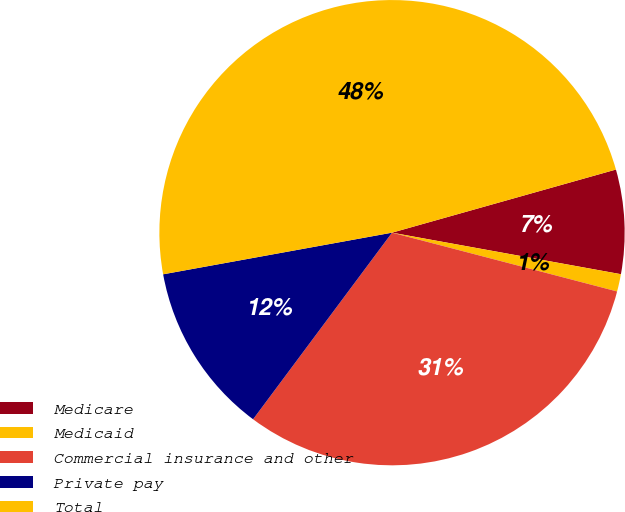Convert chart to OTSL. <chart><loc_0><loc_0><loc_500><loc_500><pie_chart><fcel>Medicare<fcel>Medicaid<fcel>Commercial insurance and other<fcel>Private pay<fcel>Total<nl><fcel>7.23%<fcel>1.21%<fcel>31.12%<fcel>11.95%<fcel>48.49%<nl></chart> 